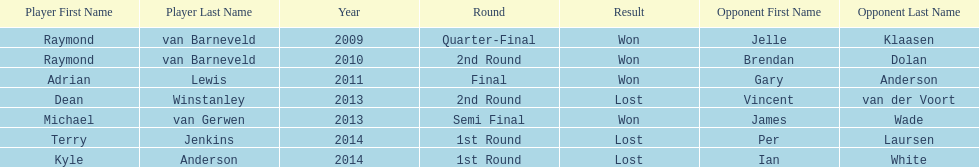Did terry jenkins or per laursen win in 2014? Per Laursen. 